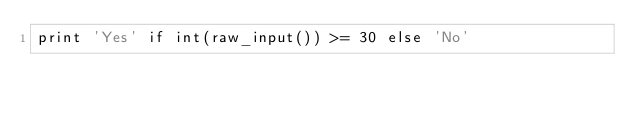<code> <loc_0><loc_0><loc_500><loc_500><_Python_>print 'Yes' if int(raw_input()) >= 30 else 'No'</code> 